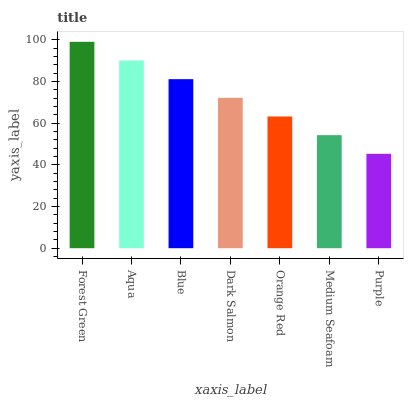Is Purple the minimum?
Answer yes or no. Yes. Is Forest Green the maximum?
Answer yes or no. Yes. Is Aqua the minimum?
Answer yes or no. No. Is Aqua the maximum?
Answer yes or no. No. Is Forest Green greater than Aqua?
Answer yes or no. Yes. Is Aqua less than Forest Green?
Answer yes or no. Yes. Is Aqua greater than Forest Green?
Answer yes or no. No. Is Forest Green less than Aqua?
Answer yes or no. No. Is Dark Salmon the high median?
Answer yes or no. Yes. Is Dark Salmon the low median?
Answer yes or no. Yes. Is Blue the high median?
Answer yes or no. No. Is Orange Red the low median?
Answer yes or no. No. 